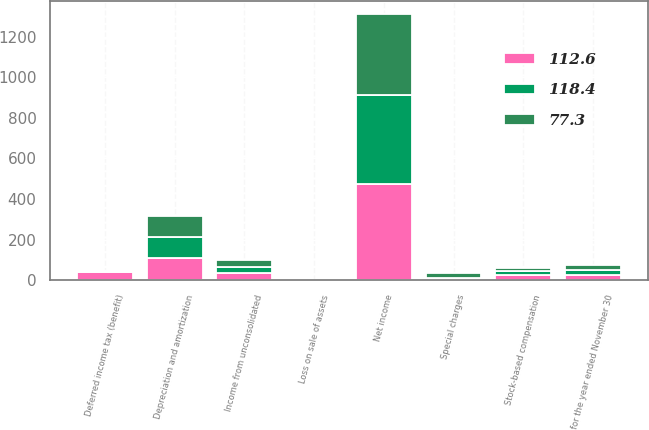Convert chart to OTSL. <chart><loc_0><loc_0><loc_500><loc_500><stacked_bar_chart><ecel><fcel>for the year ended November 30<fcel>Net income<fcel>Depreciation and amortization<fcel>Stock-based compensation<fcel>Special charges<fcel>Loss on sale of assets<fcel>Deferred income tax (benefit)<fcel>Income from unconsolidated<nl><fcel>112.6<fcel>25.6<fcel>472.3<fcel>108.7<fcel>25.6<fcel>7.2<fcel>1.5<fcel>40<fcel>36.1<nl><fcel>77.3<fcel>25.6<fcel>401.6<fcel>105.9<fcel>18.7<fcel>22.8<fcel>0.6<fcel>1<fcel>36.7<nl><fcel>118.4<fcel>25.6<fcel>437.9<fcel>102.7<fcel>18.2<fcel>5.2<fcel>1.3<fcel>6.1<fcel>29.4<nl></chart> 